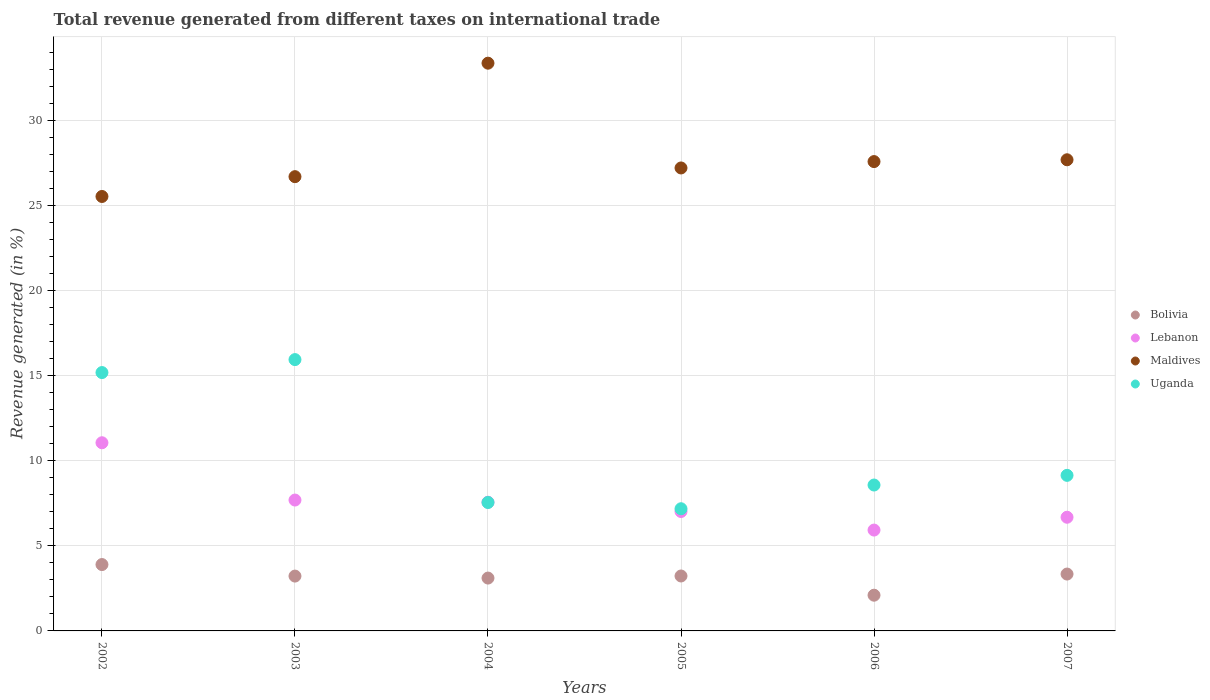What is the total revenue generated in Uganda in 2003?
Ensure brevity in your answer.  15.95. Across all years, what is the maximum total revenue generated in Bolivia?
Offer a very short reply. 3.9. Across all years, what is the minimum total revenue generated in Bolivia?
Provide a short and direct response. 2.1. In which year was the total revenue generated in Lebanon maximum?
Provide a short and direct response. 2002. In which year was the total revenue generated in Bolivia minimum?
Make the answer very short. 2006. What is the total total revenue generated in Maldives in the graph?
Ensure brevity in your answer.  168.09. What is the difference between the total revenue generated in Lebanon in 2002 and that in 2007?
Provide a succinct answer. 4.38. What is the difference between the total revenue generated in Lebanon in 2006 and the total revenue generated in Uganda in 2004?
Make the answer very short. -1.62. What is the average total revenue generated in Bolivia per year?
Give a very brief answer. 3.15. In the year 2007, what is the difference between the total revenue generated in Lebanon and total revenue generated in Uganda?
Give a very brief answer. -2.46. In how many years, is the total revenue generated in Bolivia greater than 7 %?
Ensure brevity in your answer.  0. What is the ratio of the total revenue generated in Maldives in 2002 to that in 2005?
Provide a succinct answer. 0.94. Is the total revenue generated in Maldives in 2004 less than that in 2006?
Keep it short and to the point. No. Is the difference between the total revenue generated in Lebanon in 2003 and 2007 greater than the difference between the total revenue generated in Uganda in 2003 and 2007?
Keep it short and to the point. No. What is the difference between the highest and the second highest total revenue generated in Uganda?
Provide a succinct answer. 0.76. What is the difference between the highest and the lowest total revenue generated in Lebanon?
Provide a short and direct response. 5.13. In how many years, is the total revenue generated in Lebanon greater than the average total revenue generated in Lebanon taken over all years?
Make the answer very short. 2. Is the sum of the total revenue generated in Lebanon in 2002 and 2004 greater than the maximum total revenue generated in Bolivia across all years?
Your answer should be very brief. Yes. Is it the case that in every year, the sum of the total revenue generated in Uganda and total revenue generated in Bolivia  is greater than the sum of total revenue generated in Maldives and total revenue generated in Lebanon?
Ensure brevity in your answer.  No. Is the total revenue generated in Maldives strictly greater than the total revenue generated in Bolivia over the years?
Give a very brief answer. Yes. Is the total revenue generated in Uganda strictly less than the total revenue generated in Bolivia over the years?
Keep it short and to the point. No. Are the values on the major ticks of Y-axis written in scientific E-notation?
Offer a very short reply. No. Where does the legend appear in the graph?
Your answer should be compact. Center right. How are the legend labels stacked?
Give a very brief answer. Vertical. What is the title of the graph?
Your response must be concise. Total revenue generated from different taxes on international trade. What is the label or title of the X-axis?
Your answer should be very brief. Years. What is the label or title of the Y-axis?
Your response must be concise. Revenue generated (in %). What is the Revenue generated (in %) of Bolivia in 2002?
Make the answer very short. 3.9. What is the Revenue generated (in %) in Lebanon in 2002?
Provide a short and direct response. 11.06. What is the Revenue generated (in %) of Maldives in 2002?
Provide a succinct answer. 25.53. What is the Revenue generated (in %) of Uganda in 2002?
Provide a short and direct response. 15.19. What is the Revenue generated (in %) of Bolivia in 2003?
Provide a short and direct response. 3.22. What is the Revenue generated (in %) of Lebanon in 2003?
Your answer should be very brief. 7.69. What is the Revenue generated (in %) of Maldives in 2003?
Provide a succinct answer. 26.7. What is the Revenue generated (in %) in Uganda in 2003?
Provide a succinct answer. 15.95. What is the Revenue generated (in %) of Bolivia in 2004?
Your response must be concise. 3.11. What is the Revenue generated (in %) in Lebanon in 2004?
Provide a short and direct response. 7.57. What is the Revenue generated (in %) of Maldives in 2004?
Give a very brief answer. 33.37. What is the Revenue generated (in %) of Uganda in 2004?
Give a very brief answer. 7.55. What is the Revenue generated (in %) of Bolivia in 2005?
Your answer should be very brief. 3.23. What is the Revenue generated (in %) of Lebanon in 2005?
Your response must be concise. 7.02. What is the Revenue generated (in %) of Maldives in 2005?
Provide a succinct answer. 27.21. What is the Revenue generated (in %) of Uganda in 2005?
Give a very brief answer. 7.18. What is the Revenue generated (in %) of Bolivia in 2006?
Your answer should be very brief. 2.1. What is the Revenue generated (in %) in Lebanon in 2006?
Make the answer very short. 5.93. What is the Revenue generated (in %) in Maldives in 2006?
Your answer should be compact. 27.59. What is the Revenue generated (in %) in Uganda in 2006?
Give a very brief answer. 8.58. What is the Revenue generated (in %) in Bolivia in 2007?
Ensure brevity in your answer.  3.34. What is the Revenue generated (in %) in Lebanon in 2007?
Provide a short and direct response. 6.68. What is the Revenue generated (in %) of Maldives in 2007?
Give a very brief answer. 27.69. What is the Revenue generated (in %) in Uganda in 2007?
Give a very brief answer. 9.14. Across all years, what is the maximum Revenue generated (in %) of Bolivia?
Keep it short and to the point. 3.9. Across all years, what is the maximum Revenue generated (in %) in Lebanon?
Make the answer very short. 11.06. Across all years, what is the maximum Revenue generated (in %) in Maldives?
Provide a short and direct response. 33.37. Across all years, what is the maximum Revenue generated (in %) of Uganda?
Make the answer very short. 15.95. Across all years, what is the minimum Revenue generated (in %) of Bolivia?
Your answer should be very brief. 2.1. Across all years, what is the minimum Revenue generated (in %) of Lebanon?
Ensure brevity in your answer.  5.93. Across all years, what is the minimum Revenue generated (in %) in Maldives?
Your answer should be very brief. 25.53. Across all years, what is the minimum Revenue generated (in %) in Uganda?
Offer a very short reply. 7.18. What is the total Revenue generated (in %) in Bolivia in the graph?
Provide a short and direct response. 18.9. What is the total Revenue generated (in %) of Lebanon in the graph?
Your response must be concise. 45.94. What is the total Revenue generated (in %) of Maldives in the graph?
Ensure brevity in your answer.  168.09. What is the total Revenue generated (in %) of Uganda in the graph?
Your response must be concise. 63.58. What is the difference between the Revenue generated (in %) in Bolivia in 2002 and that in 2003?
Your answer should be very brief. 0.68. What is the difference between the Revenue generated (in %) of Lebanon in 2002 and that in 2003?
Give a very brief answer. 3.37. What is the difference between the Revenue generated (in %) in Maldives in 2002 and that in 2003?
Your answer should be compact. -1.16. What is the difference between the Revenue generated (in %) of Uganda in 2002 and that in 2003?
Provide a succinct answer. -0.76. What is the difference between the Revenue generated (in %) in Bolivia in 2002 and that in 2004?
Your answer should be very brief. 0.79. What is the difference between the Revenue generated (in %) in Lebanon in 2002 and that in 2004?
Offer a very short reply. 3.49. What is the difference between the Revenue generated (in %) in Maldives in 2002 and that in 2004?
Provide a succinct answer. -7.83. What is the difference between the Revenue generated (in %) of Uganda in 2002 and that in 2004?
Your response must be concise. 7.64. What is the difference between the Revenue generated (in %) of Bolivia in 2002 and that in 2005?
Make the answer very short. 0.67. What is the difference between the Revenue generated (in %) in Lebanon in 2002 and that in 2005?
Your response must be concise. 4.04. What is the difference between the Revenue generated (in %) in Maldives in 2002 and that in 2005?
Offer a very short reply. -1.68. What is the difference between the Revenue generated (in %) in Uganda in 2002 and that in 2005?
Ensure brevity in your answer.  8. What is the difference between the Revenue generated (in %) of Bolivia in 2002 and that in 2006?
Ensure brevity in your answer.  1.8. What is the difference between the Revenue generated (in %) in Lebanon in 2002 and that in 2006?
Your answer should be compact. 5.13. What is the difference between the Revenue generated (in %) in Maldives in 2002 and that in 2006?
Your answer should be very brief. -2.05. What is the difference between the Revenue generated (in %) of Uganda in 2002 and that in 2006?
Make the answer very short. 6.61. What is the difference between the Revenue generated (in %) of Bolivia in 2002 and that in 2007?
Give a very brief answer. 0.56. What is the difference between the Revenue generated (in %) in Lebanon in 2002 and that in 2007?
Make the answer very short. 4.38. What is the difference between the Revenue generated (in %) of Maldives in 2002 and that in 2007?
Provide a short and direct response. -2.16. What is the difference between the Revenue generated (in %) in Uganda in 2002 and that in 2007?
Your answer should be compact. 6.04. What is the difference between the Revenue generated (in %) of Bolivia in 2003 and that in 2004?
Keep it short and to the point. 0.12. What is the difference between the Revenue generated (in %) of Lebanon in 2003 and that in 2004?
Ensure brevity in your answer.  0.13. What is the difference between the Revenue generated (in %) of Maldives in 2003 and that in 2004?
Provide a short and direct response. -6.67. What is the difference between the Revenue generated (in %) in Uganda in 2003 and that in 2004?
Provide a short and direct response. 8.4. What is the difference between the Revenue generated (in %) of Bolivia in 2003 and that in 2005?
Keep it short and to the point. -0.01. What is the difference between the Revenue generated (in %) in Lebanon in 2003 and that in 2005?
Your response must be concise. 0.67. What is the difference between the Revenue generated (in %) in Maldives in 2003 and that in 2005?
Your response must be concise. -0.51. What is the difference between the Revenue generated (in %) in Uganda in 2003 and that in 2005?
Make the answer very short. 8.77. What is the difference between the Revenue generated (in %) in Bolivia in 2003 and that in 2006?
Give a very brief answer. 1.12. What is the difference between the Revenue generated (in %) in Lebanon in 2003 and that in 2006?
Provide a succinct answer. 1.76. What is the difference between the Revenue generated (in %) in Maldives in 2003 and that in 2006?
Provide a short and direct response. -0.89. What is the difference between the Revenue generated (in %) in Uganda in 2003 and that in 2006?
Your response must be concise. 7.37. What is the difference between the Revenue generated (in %) in Bolivia in 2003 and that in 2007?
Offer a very short reply. -0.12. What is the difference between the Revenue generated (in %) in Lebanon in 2003 and that in 2007?
Provide a short and direct response. 1.01. What is the difference between the Revenue generated (in %) in Maldives in 2003 and that in 2007?
Provide a short and direct response. -0.99. What is the difference between the Revenue generated (in %) of Uganda in 2003 and that in 2007?
Provide a succinct answer. 6.8. What is the difference between the Revenue generated (in %) in Bolivia in 2004 and that in 2005?
Keep it short and to the point. -0.12. What is the difference between the Revenue generated (in %) of Lebanon in 2004 and that in 2005?
Provide a short and direct response. 0.55. What is the difference between the Revenue generated (in %) of Maldives in 2004 and that in 2005?
Your response must be concise. 6.16. What is the difference between the Revenue generated (in %) of Uganda in 2004 and that in 2005?
Your answer should be very brief. 0.37. What is the difference between the Revenue generated (in %) in Bolivia in 2004 and that in 2006?
Your answer should be very brief. 1.01. What is the difference between the Revenue generated (in %) of Lebanon in 2004 and that in 2006?
Make the answer very short. 1.64. What is the difference between the Revenue generated (in %) in Maldives in 2004 and that in 2006?
Make the answer very short. 5.78. What is the difference between the Revenue generated (in %) of Uganda in 2004 and that in 2006?
Make the answer very short. -1.03. What is the difference between the Revenue generated (in %) of Bolivia in 2004 and that in 2007?
Offer a very short reply. -0.24. What is the difference between the Revenue generated (in %) in Lebanon in 2004 and that in 2007?
Make the answer very short. 0.88. What is the difference between the Revenue generated (in %) of Maldives in 2004 and that in 2007?
Keep it short and to the point. 5.68. What is the difference between the Revenue generated (in %) of Uganda in 2004 and that in 2007?
Your answer should be compact. -1.6. What is the difference between the Revenue generated (in %) in Bolivia in 2005 and that in 2006?
Provide a short and direct response. 1.13. What is the difference between the Revenue generated (in %) in Lebanon in 2005 and that in 2006?
Ensure brevity in your answer.  1.09. What is the difference between the Revenue generated (in %) of Maldives in 2005 and that in 2006?
Your answer should be very brief. -0.37. What is the difference between the Revenue generated (in %) in Uganda in 2005 and that in 2006?
Your response must be concise. -1.39. What is the difference between the Revenue generated (in %) in Bolivia in 2005 and that in 2007?
Give a very brief answer. -0.11. What is the difference between the Revenue generated (in %) in Lebanon in 2005 and that in 2007?
Ensure brevity in your answer.  0.34. What is the difference between the Revenue generated (in %) of Maldives in 2005 and that in 2007?
Give a very brief answer. -0.48. What is the difference between the Revenue generated (in %) in Uganda in 2005 and that in 2007?
Provide a succinct answer. -1.96. What is the difference between the Revenue generated (in %) in Bolivia in 2006 and that in 2007?
Provide a short and direct response. -1.24. What is the difference between the Revenue generated (in %) of Lebanon in 2006 and that in 2007?
Offer a very short reply. -0.75. What is the difference between the Revenue generated (in %) of Maldives in 2006 and that in 2007?
Provide a succinct answer. -0.11. What is the difference between the Revenue generated (in %) in Uganda in 2006 and that in 2007?
Offer a very short reply. -0.57. What is the difference between the Revenue generated (in %) of Bolivia in 2002 and the Revenue generated (in %) of Lebanon in 2003?
Your answer should be very brief. -3.79. What is the difference between the Revenue generated (in %) of Bolivia in 2002 and the Revenue generated (in %) of Maldives in 2003?
Provide a succinct answer. -22.8. What is the difference between the Revenue generated (in %) in Bolivia in 2002 and the Revenue generated (in %) in Uganda in 2003?
Your answer should be compact. -12.05. What is the difference between the Revenue generated (in %) of Lebanon in 2002 and the Revenue generated (in %) of Maldives in 2003?
Keep it short and to the point. -15.64. What is the difference between the Revenue generated (in %) in Lebanon in 2002 and the Revenue generated (in %) in Uganda in 2003?
Your response must be concise. -4.89. What is the difference between the Revenue generated (in %) of Maldives in 2002 and the Revenue generated (in %) of Uganda in 2003?
Provide a succinct answer. 9.59. What is the difference between the Revenue generated (in %) of Bolivia in 2002 and the Revenue generated (in %) of Lebanon in 2004?
Make the answer very short. -3.66. What is the difference between the Revenue generated (in %) of Bolivia in 2002 and the Revenue generated (in %) of Maldives in 2004?
Your answer should be compact. -29.47. What is the difference between the Revenue generated (in %) in Bolivia in 2002 and the Revenue generated (in %) in Uganda in 2004?
Provide a succinct answer. -3.65. What is the difference between the Revenue generated (in %) in Lebanon in 2002 and the Revenue generated (in %) in Maldives in 2004?
Provide a short and direct response. -22.31. What is the difference between the Revenue generated (in %) of Lebanon in 2002 and the Revenue generated (in %) of Uganda in 2004?
Make the answer very short. 3.51. What is the difference between the Revenue generated (in %) in Maldives in 2002 and the Revenue generated (in %) in Uganda in 2004?
Keep it short and to the point. 17.99. What is the difference between the Revenue generated (in %) of Bolivia in 2002 and the Revenue generated (in %) of Lebanon in 2005?
Ensure brevity in your answer.  -3.12. What is the difference between the Revenue generated (in %) in Bolivia in 2002 and the Revenue generated (in %) in Maldives in 2005?
Keep it short and to the point. -23.31. What is the difference between the Revenue generated (in %) of Bolivia in 2002 and the Revenue generated (in %) of Uganda in 2005?
Offer a very short reply. -3.28. What is the difference between the Revenue generated (in %) of Lebanon in 2002 and the Revenue generated (in %) of Maldives in 2005?
Ensure brevity in your answer.  -16.15. What is the difference between the Revenue generated (in %) in Lebanon in 2002 and the Revenue generated (in %) in Uganda in 2005?
Provide a short and direct response. 3.88. What is the difference between the Revenue generated (in %) of Maldives in 2002 and the Revenue generated (in %) of Uganda in 2005?
Keep it short and to the point. 18.35. What is the difference between the Revenue generated (in %) of Bolivia in 2002 and the Revenue generated (in %) of Lebanon in 2006?
Provide a succinct answer. -2.03. What is the difference between the Revenue generated (in %) in Bolivia in 2002 and the Revenue generated (in %) in Maldives in 2006?
Ensure brevity in your answer.  -23.68. What is the difference between the Revenue generated (in %) of Bolivia in 2002 and the Revenue generated (in %) of Uganda in 2006?
Your answer should be compact. -4.67. What is the difference between the Revenue generated (in %) in Lebanon in 2002 and the Revenue generated (in %) in Maldives in 2006?
Offer a very short reply. -16.53. What is the difference between the Revenue generated (in %) in Lebanon in 2002 and the Revenue generated (in %) in Uganda in 2006?
Make the answer very short. 2.48. What is the difference between the Revenue generated (in %) in Maldives in 2002 and the Revenue generated (in %) in Uganda in 2006?
Keep it short and to the point. 16.96. What is the difference between the Revenue generated (in %) of Bolivia in 2002 and the Revenue generated (in %) of Lebanon in 2007?
Your answer should be very brief. -2.78. What is the difference between the Revenue generated (in %) of Bolivia in 2002 and the Revenue generated (in %) of Maldives in 2007?
Offer a very short reply. -23.79. What is the difference between the Revenue generated (in %) in Bolivia in 2002 and the Revenue generated (in %) in Uganda in 2007?
Offer a very short reply. -5.24. What is the difference between the Revenue generated (in %) of Lebanon in 2002 and the Revenue generated (in %) of Maldives in 2007?
Your answer should be compact. -16.63. What is the difference between the Revenue generated (in %) of Lebanon in 2002 and the Revenue generated (in %) of Uganda in 2007?
Offer a terse response. 1.92. What is the difference between the Revenue generated (in %) in Maldives in 2002 and the Revenue generated (in %) in Uganda in 2007?
Offer a very short reply. 16.39. What is the difference between the Revenue generated (in %) in Bolivia in 2003 and the Revenue generated (in %) in Lebanon in 2004?
Offer a terse response. -4.34. What is the difference between the Revenue generated (in %) of Bolivia in 2003 and the Revenue generated (in %) of Maldives in 2004?
Provide a short and direct response. -30.15. What is the difference between the Revenue generated (in %) in Bolivia in 2003 and the Revenue generated (in %) in Uganda in 2004?
Your answer should be compact. -4.33. What is the difference between the Revenue generated (in %) in Lebanon in 2003 and the Revenue generated (in %) in Maldives in 2004?
Make the answer very short. -25.68. What is the difference between the Revenue generated (in %) of Lebanon in 2003 and the Revenue generated (in %) of Uganda in 2004?
Your answer should be very brief. 0.14. What is the difference between the Revenue generated (in %) in Maldives in 2003 and the Revenue generated (in %) in Uganda in 2004?
Provide a succinct answer. 19.15. What is the difference between the Revenue generated (in %) of Bolivia in 2003 and the Revenue generated (in %) of Lebanon in 2005?
Your answer should be compact. -3.8. What is the difference between the Revenue generated (in %) of Bolivia in 2003 and the Revenue generated (in %) of Maldives in 2005?
Your answer should be very brief. -23.99. What is the difference between the Revenue generated (in %) of Bolivia in 2003 and the Revenue generated (in %) of Uganda in 2005?
Your answer should be compact. -3.96. What is the difference between the Revenue generated (in %) in Lebanon in 2003 and the Revenue generated (in %) in Maldives in 2005?
Your answer should be very brief. -19.52. What is the difference between the Revenue generated (in %) of Lebanon in 2003 and the Revenue generated (in %) of Uganda in 2005?
Offer a very short reply. 0.51. What is the difference between the Revenue generated (in %) of Maldives in 2003 and the Revenue generated (in %) of Uganda in 2005?
Give a very brief answer. 19.52. What is the difference between the Revenue generated (in %) of Bolivia in 2003 and the Revenue generated (in %) of Lebanon in 2006?
Offer a very short reply. -2.7. What is the difference between the Revenue generated (in %) in Bolivia in 2003 and the Revenue generated (in %) in Maldives in 2006?
Make the answer very short. -24.36. What is the difference between the Revenue generated (in %) of Bolivia in 2003 and the Revenue generated (in %) of Uganda in 2006?
Ensure brevity in your answer.  -5.35. What is the difference between the Revenue generated (in %) in Lebanon in 2003 and the Revenue generated (in %) in Maldives in 2006?
Offer a terse response. -19.89. What is the difference between the Revenue generated (in %) in Lebanon in 2003 and the Revenue generated (in %) in Uganda in 2006?
Your response must be concise. -0.88. What is the difference between the Revenue generated (in %) of Maldives in 2003 and the Revenue generated (in %) of Uganda in 2006?
Give a very brief answer. 18.12. What is the difference between the Revenue generated (in %) of Bolivia in 2003 and the Revenue generated (in %) of Lebanon in 2007?
Keep it short and to the point. -3.46. What is the difference between the Revenue generated (in %) of Bolivia in 2003 and the Revenue generated (in %) of Maldives in 2007?
Offer a very short reply. -24.47. What is the difference between the Revenue generated (in %) of Bolivia in 2003 and the Revenue generated (in %) of Uganda in 2007?
Your response must be concise. -5.92. What is the difference between the Revenue generated (in %) of Lebanon in 2003 and the Revenue generated (in %) of Maldives in 2007?
Provide a succinct answer. -20. What is the difference between the Revenue generated (in %) of Lebanon in 2003 and the Revenue generated (in %) of Uganda in 2007?
Ensure brevity in your answer.  -1.45. What is the difference between the Revenue generated (in %) of Maldives in 2003 and the Revenue generated (in %) of Uganda in 2007?
Provide a succinct answer. 17.56. What is the difference between the Revenue generated (in %) in Bolivia in 2004 and the Revenue generated (in %) in Lebanon in 2005?
Provide a succinct answer. -3.91. What is the difference between the Revenue generated (in %) of Bolivia in 2004 and the Revenue generated (in %) of Maldives in 2005?
Provide a succinct answer. -24.1. What is the difference between the Revenue generated (in %) in Bolivia in 2004 and the Revenue generated (in %) in Uganda in 2005?
Offer a very short reply. -4.07. What is the difference between the Revenue generated (in %) of Lebanon in 2004 and the Revenue generated (in %) of Maldives in 2005?
Ensure brevity in your answer.  -19.65. What is the difference between the Revenue generated (in %) in Lebanon in 2004 and the Revenue generated (in %) in Uganda in 2005?
Your answer should be compact. 0.38. What is the difference between the Revenue generated (in %) in Maldives in 2004 and the Revenue generated (in %) in Uganda in 2005?
Provide a succinct answer. 26.19. What is the difference between the Revenue generated (in %) of Bolivia in 2004 and the Revenue generated (in %) of Lebanon in 2006?
Provide a succinct answer. -2.82. What is the difference between the Revenue generated (in %) of Bolivia in 2004 and the Revenue generated (in %) of Maldives in 2006?
Your answer should be very brief. -24.48. What is the difference between the Revenue generated (in %) of Bolivia in 2004 and the Revenue generated (in %) of Uganda in 2006?
Offer a very short reply. -5.47. What is the difference between the Revenue generated (in %) in Lebanon in 2004 and the Revenue generated (in %) in Maldives in 2006?
Make the answer very short. -20.02. What is the difference between the Revenue generated (in %) of Lebanon in 2004 and the Revenue generated (in %) of Uganda in 2006?
Ensure brevity in your answer.  -1.01. What is the difference between the Revenue generated (in %) of Maldives in 2004 and the Revenue generated (in %) of Uganda in 2006?
Offer a terse response. 24.79. What is the difference between the Revenue generated (in %) in Bolivia in 2004 and the Revenue generated (in %) in Lebanon in 2007?
Offer a very short reply. -3.58. What is the difference between the Revenue generated (in %) of Bolivia in 2004 and the Revenue generated (in %) of Maldives in 2007?
Provide a short and direct response. -24.59. What is the difference between the Revenue generated (in %) in Bolivia in 2004 and the Revenue generated (in %) in Uganda in 2007?
Ensure brevity in your answer.  -6.04. What is the difference between the Revenue generated (in %) of Lebanon in 2004 and the Revenue generated (in %) of Maldives in 2007?
Your answer should be very brief. -20.13. What is the difference between the Revenue generated (in %) in Lebanon in 2004 and the Revenue generated (in %) in Uganda in 2007?
Give a very brief answer. -1.58. What is the difference between the Revenue generated (in %) in Maldives in 2004 and the Revenue generated (in %) in Uganda in 2007?
Give a very brief answer. 24.23. What is the difference between the Revenue generated (in %) in Bolivia in 2005 and the Revenue generated (in %) in Lebanon in 2006?
Offer a very short reply. -2.7. What is the difference between the Revenue generated (in %) in Bolivia in 2005 and the Revenue generated (in %) in Maldives in 2006?
Your response must be concise. -24.36. What is the difference between the Revenue generated (in %) in Bolivia in 2005 and the Revenue generated (in %) in Uganda in 2006?
Your answer should be very brief. -5.35. What is the difference between the Revenue generated (in %) in Lebanon in 2005 and the Revenue generated (in %) in Maldives in 2006?
Keep it short and to the point. -20.57. What is the difference between the Revenue generated (in %) in Lebanon in 2005 and the Revenue generated (in %) in Uganda in 2006?
Ensure brevity in your answer.  -1.56. What is the difference between the Revenue generated (in %) of Maldives in 2005 and the Revenue generated (in %) of Uganda in 2006?
Give a very brief answer. 18.64. What is the difference between the Revenue generated (in %) in Bolivia in 2005 and the Revenue generated (in %) in Lebanon in 2007?
Your answer should be compact. -3.45. What is the difference between the Revenue generated (in %) of Bolivia in 2005 and the Revenue generated (in %) of Maldives in 2007?
Make the answer very short. -24.46. What is the difference between the Revenue generated (in %) in Bolivia in 2005 and the Revenue generated (in %) in Uganda in 2007?
Your answer should be compact. -5.91. What is the difference between the Revenue generated (in %) in Lebanon in 2005 and the Revenue generated (in %) in Maldives in 2007?
Make the answer very short. -20.67. What is the difference between the Revenue generated (in %) in Lebanon in 2005 and the Revenue generated (in %) in Uganda in 2007?
Keep it short and to the point. -2.12. What is the difference between the Revenue generated (in %) in Maldives in 2005 and the Revenue generated (in %) in Uganda in 2007?
Provide a short and direct response. 18.07. What is the difference between the Revenue generated (in %) of Bolivia in 2006 and the Revenue generated (in %) of Lebanon in 2007?
Ensure brevity in your answer.  -4.58. What is the difference between the Revenue generated (in %) of Bolivia in 2006 and the Revenue generated (in %) of Maldives in 2007?
Your response must be concise. -25.59. What is the difference between the Revenue generated (in %) of Bolivia in 2006 and the Revenue generated (in %) of Uganda in 2007?
Your answer should be compact. -7.04. What is the difference between the Revenue generated (in %) in Lebanon in 2006 and the Revenue generated (in %) in Maldives in 2007?
Offer a terse response. -21.76. What is the difference between the Revenue generated (in %) of Lebanon in 2006 and the Revenue generated (in %) of Uganda in 2007?
Make the answer very short. -3.22. What is the difference between the Revenue generated (in %) in Maldives in 2006 and the Revenue generated (in %) in Uganda in 2007?
Your answer should be compact. 18.44. What is the average Revenue generated (in %) of Bolivia per year?
Make the answer very short. 3.15. What is the average Revenue generated (in %) of Lebanon per year?
Offer a terse response. 7.66. What is the average Revenue generated (in %) of Maldives per year?
Ensure brevity in your answer.  28.02. What is the average Revenue generated (in %) in Uganda per year?
Ensure brevity in your answer.  10.6. In the year 2002, what is the difference between the Revenue generated (in %) of Bolivia and Revenue generated (in %) of Lebanon?
Keep it short and to the point. -7.16. In the year 2002, what is the difference between the Revenue generated (in %) of Bolivia and Revenue generated (in %) of Maldives?
Provide a short and direct response. -21.63. In the year 2002, what is the difference between the Revenue generated (in %) of Bolivia and Revenue generated (in %) of Uganda?
Provide a short and direct response. -11.28. In the year 2002, what is the difference between the Revenue generated (in %) of Lebanon and Revenue generated (in %) of Maldives?
Ensure brevity in your answer.  -14.48. In the year 2002, what is the difference between the Revenue generated (in %) of Lebanon and Revenue generated (in %) of Uganda?
Provide a short and direct response. -4.13. In the year 2002, what is the difference between the Revenue generated (in %) in Maldives and Revenue generated (in %) in Uganda?
Give a very brief answer. 10.35. In the year 2003, what is the difference between the Revenue generated (in %) of Bolivia and Revenue generated (in %) of Lebanon?
Provide a succinct answer. -4.47. In the year 2003, what is the difference between the Revenue generated (in %) in Bolivia and Revenue generated (in %) in Maldives?
Provide a short and direct response. -23.48. In the year 2003, what is the difference between the Revenue generated (in %) in Bolivia and Revenue generated (in %) in Uganda?
Give a very brief answer. -12.72. In the year 2003, what is the difference between the Revenue generated (in %) of Lebanon and Revenue generated (in %) of Maldives?
Provide a short and direct response. -19.01. In the year 2003, what is the difference between the Revenue generated (in %) of Lebanon and Revenue generated (in %) of Uganda?
Make the answer very short. -8.26. In the year 2003, what is the difference between the Revenue generated (in %) of Maldives and Revenue generated (in %) of Uganda?
Make the answer very short. 10.75. In the year 2004, what is the difference between the Revenue generated (in %) of Bolivia and Revenue generated (in %) of Lebanon?
Your answer should be very brief. -4.46. In the year 2004, what is the difference between the Revenue generated (in %) of Bolivia and Revenue generated (in %) of Maldives?
Give a very brief answer. -30.26. In the year 2004, what is the difference between the Revenue generated (in %) in Bolivia and Revenue generated (in %) in Uganda?
Provide a short and direct response. -4.44. In the year 2004, what is the difference between the Revenue generated (in %) in Lebanon and Revenue generated (in %) in Maldives?
Your answer should be compact. -25.8. In the year 2004, what is the difference between the Revenue generated (in %) in Lebanon and Revenue generated (in %) in Uganda?
Provide a succinct answer. 0.02. In the year 2004, what is the difference between the Revenue generated (in %) in Maldives and Revenue generated (in %) in Uganda?
Provide a succinct answer. 25.82. In the year 2005, what is the difference between the Revenue generated (in %) in Bolivia and Revenue generated (in %) in Lebanon?
Make the answer very short. -3.79. In the year 2005, what is the difference between the Revenue generated (in %) of Bolivia and Revenue generated (in %) of Maldives?
Your answer should be compact. -23.98. In the year 2005, what is the difference between the Revenue generated (in %) in Bolivia and Revenue generated (in %) in Uganda?
Offer a very short reply. -3.95. In the year 2005, what is the difference between the Revenue generated (in %) in Lebanon and Revenue generated (in %) in Maldives?
Your answer should be very brief. -20.19. In the year 2005, what is the difference between the Revenue generated (in %) of Lebanon and Revenue generated (in %) of Uganda?
Your answer should be very brief. -0.16. In the year 2005, what is the difference between the Revenue generated (in %) in Maldives and Revenue generated (in %) in Uganda?
Your answer should be very brief. 20.03. In the year 2006, what is the difference between the Revenue generated (in %) in Bolivia and Revenue generated (in %) in Lebanon?
Your answer should be compact. -3.83. In the year 2006, what is the difference between the Revenue generated (in %) in Bolivia and Revenue generated (in %) in Maldives?
Offer a terse response. -25.49. In the year 2006, what is the difference between the Revenue generated (in %) of Bolivia and Revenue generated (in %) of Uganda?
Ensure brevity in your answer.  -6.48. In the year 2006, what is the difference between the Revenue generated (in %) of Lebanon and Revenue generated (in %) of Maldives?
Give a very brief answer. -21.66. In the year 2006, what is the difference between the Revenue generated (in %) of Lebanon and Revenue generated (in %) of Uganda?
Ensure brevity in your answer.  -2.65. In the year 2006, what is the difference between the Revenue generated (in %) of Maldives and Revenue generated (in %) of Uganda?
Make the answer very short. 19.01. In the year 2007, what is the difference between the Revenue generated (in %) in Bolivia and Revenue generated (in %) in Lebanon?
Ensure brevity in your answer.  -3.34. In the year 2007, what is the difference between the Revenue generated (in %) in Bolivia and Revenue generated (in %) in Maldives?
Your answer should be very brief. -24.35. In the year 2007, what is the difference between the Revenue generated (in %) of Bolivia and Revenue generated (in %) of Uganda?
Give a very brief answer. -5.8. In the year 2007, what is the difference between the Revenue generated (in %) of Lebanon and Revenue generated (in %) of Maldives?
Your answer should be very brief. -21.01. In the year 2007, what is the difference between the Revenue generated (in %) in Lebanon and Revenue generated (in %) in Uganda?
Offer a terse response. -2.46. In the year 2007, what is the difference between the Revenue generated (in %) in Maldives and Revenue generated (in %) in Uganda?
Provide a succinct answer. 18.55. What is the ratio of the Revenue generated (in %) of Bolivia in 2002 to that in 2003?
Keep it short and to the point. 1.21. What is the ratio of the Revenue generated (in %) in Lebanon in 2002 to that in 2003?
Give a very brief answer. 1.44. What is the ratio of the Revenue generated (in %) of Maldives in 2002 to that in 2003?
Provide a short and direct response. 0.96. What is the ratio of the Revenue generated (in %) in Uganda in 2002 to that in 2003?
Offer a very short reply. 0.95. What is the ratio of the Revenue generated (in %) in Bolivia in 2002 to that in 2004?
Your answer should be compact. 1.26. What is the ratio of the Revenue generated (in %) in Lebanon in 2002 to that in 2004?
Provide a succinct answer. 1.46. What is the ratio of the Revenue generated (in %) of Maldives in 2002 to that in 2004?
Provide a short and direct response. 0.77. What is the ratio of the Revenue generated (in %) of Uganda in 2002 to that in 2004?
Make the answer very short. 2.01. What is the ratio of the Revenue generated (in %) of Bolivia in 2002 to that in 2005?
Make the answer very short. 1.21. What is the ratio of the Revenue generated (in %) of Lebanon in 2002 to that in 2005?
Ensure brevity in your answer.  1.58. What is the ratio of the Revenue generated (in %) in Maldives in 2002 to that in 2005?
Provide a succinct answer. 0.94. What is the ratio of the Revenue generated (in %) in Uganda in 2002 to that in 2005?
Your answer should be very brief. 2.11. What is the ratio of the Revenue generated (in %) of Bolivia in 2002 to that in 2006?
Offer a very short reply. 1.86. What is the ratio of the Revenue generated (in %) of Lebanon in 2002 to that in 2006?
Make the answer very short. 1.87. What is the ratio of the Revenue generated (in %) in Maldives in 2002 to that in 2006?
Keep it short and to the point. 0.93. What is the ratio of the Revenue generated (in %) in Uganda in 2002 to that in 2006?
Offer a terse response. 1.77. What is the ratio of the Revenue generated (in %) of Bolivia in 2002 to that in 2007?
Ensure brevity in your answer.  1.17. What is the ratio of the Revenue generated (in %) in Lebanon in 2002 to that in 2007?
Ensure brevity in your answer.  1.66. What is the ratio of the Revenue generated (in %) in Maldives in 2002 to that in 2007?
Offer a terse response. 0.92. What is the ratio of the Revenue generated (in %) of Uganda in 2002 to that in 2007?
Keep it short and to the point. 1.66. What is the ratio of the Revenue generated (in %) in Bolivia in 2003 to that in 2004?
Ensure brevity in your answer.  1.04. What is the ratio of the Revenue generated (in %) of Lebanon in 2003 to that in 2004?
Provide a short and direct response. 1.02. What is the ratio of the Revenue generated (in %) of Maldives in 2003 to that in 2004?
Offer a terse response. 0.8. What is the ratio of the Revenue generated (in %) in Uganda in 2003 to that in 2004?
Make the answer very short. 2.11. What is the ratio of the Revenue generated (in %) of Bolivia in 2003 to that in 2005?
Offer a terse response. 1. What is the ratio of the Revenue generated (in %) in Lebanon in 2003 to that in 2005?
Provide a succinct answer. 1.1. What is the ratio of the Revenue generated (in %) of Maldives in 2003 to that in 2005?
Make the answer very short. 0.98. What is the ratio of the Revenue generated (in %) in Uganda in 2003 to that in 2005?
Provide a succinct answer. 2.22. What is the ratio of the Revenue generated (in %) of Bolivia in 2003 to that in 2006?
Provide a succinct answer. 1.53. What is the ratio of the Revenue generated (in %) of Lebanon in 2003 to that in 2006?
Your response must be concise. 1.3. What is the ratio of the Revenue generated (in %) in Maldives in 2003 to that in 2006?
Your answer should be very brief. 0.97. What is the ratio of the Revenue generated (in %) in Uganda in 2003 to that in 2006?
Provide a short and direct response. 1.86. What is the ratio of the Revenue generated (in %) in Bolivia in 2003 to that in 2007?
Keep it short and to the point. 0.96. What is the ratio of the Revenue generated (in %) of Lebanon in 2003 to that in 2007?
Keep it short and to the point. 1.15. What is the ratio of the Revenue generated (in %) of Maldives in 2003 to that in 2007?
Offer a very short reply. 0.96. What is the ratio of the Revenue generated (in %) in Uganda in 2003 to that in 2007?
Give a very brief answer. 1.74. What is the ratio of the Revenue generated (in %) in Lebanon in 2004 to that in 2005?
Your answer should be very brief. 1.08. What is the ratio of the Revenue generated (in %) of Maldives in 2004 to that in 2005?
Offer a very short reply. 1.23. What is the ratio of the Revenue generated (in %) in Uganda in 2004 to that in 2005?
Make the answer very short. 1.05. What is the ratio of the Revenue generated (in %) of Bolivia in 2004 to that in 2006?
Provide a succinct answer. 1.48. What is the ratio of the Revenue generated (in %) of Lebanon in 2004 to that in 2006?
Your answer should be compact. 1.28. What is the ratio of the Revenue generated (in %) in Maldives in 2004 to that in 2006?
Keep it short and to the point. 1.21. What is the ratio of the Revenue generated (in %) of Uganda in 2004 to that in 2006?
Your response must be concise. 0.88. What is the ratio of the Revenue generated (in %) in Bolivia in 2004 to that in 2007?
Provide a succinct answer. 0.93. What is the ratio of the Revenue generated (in %) in Lebanon in 2004 to that in 2007?
Ensure brevity in your answer.  1.13. What is the ratio of the Revenue generated (in %) of Maldives in 2004 to that in 2007?
Your response must be concise. 1.21. What is the ratio of the Revenue generated (in %) in Uganda in 2004 to that in 2007?
Offer a terse response. 0.83. What is the ratio of the Revenue generated (in %) of Bolivia in 2005 to that in 2006?
Offer a terse response. 1.54. What is the ratio of the Revenue generated (in %) of Lebanon in 2005 to that in 2006?
Ensure brevity in your answer.  1.18. What is the ratio of the Revenue generated (in %) of Maldives in 2005 to that in 2006?
Your answer should be compact. 0.99. What is the ratio of the Revenue generated (in %) in Uganda in 2005 to that in 2006?
Keep it short and to the point. 0.84. What is the ratio of the Revenue generated (in %) in Bolivia in 2005 to that in 2007?
Offer a terse response. 0.97. What is the ratio of the Revenue generated (in %) in Lebanon in 2005 to that in 2007?
Your answer should be very brief. 1.05. What is the ratio of the Revenue generated (in %) of Maldives in 2005 to that in 2007?
Your response must be concise. 0.98. What is the ratio of the Revenue generated (in %) of Uganda in 2005 to that in 2007?
Offer a very short reply. 0.79. What is the ratio of the Revenue generated (in %) in Bolivia in 2006 to that in 2007?
Make the answer very short. 0.63. What is the ratio of the Revenue generated (in %) in Lebanon in 2006 to that in 2007?
Keep it short and to the point. 0.89. What is the ratio of the Revenue generated (in %) in Uganda in 2006 to that in 2007?
Offer a terse response. 0.94. What is the difference between the highest and the second highest Revenue generated (in %) of Bolivia?
Ensure brevity in your answer.  0.56. What is the difference between the highest and the second highest Revenue generated (in %) of Lebanon?
Offer a very short reply. 3.37. What is the difference between the highest and the second highest Revenue generated (in %) of Maldives?
Make the answer very short. 5.68. What is the difference between the highest and the second highest Revenue generated (in %) in Uganda?
Your answer should be very brief. 0.76. What is the difference between the highest and the lowest Revenue generated (in %) of Bolivia?
Make the answer very short. 1.8. What is the difference between the highest and the lowest Revenue generated (in %) in Lebanon?
Provide a short and direct response. 5.13. What is the difference between the highest and the lowest Revenue generated (in %) of Maldives?
Ensure brevity in your answer.  7.83. What is the difference between the highest and the lowest Revenue generated (in %) in Uganda?
Your answer should be very brief. 8.77. 